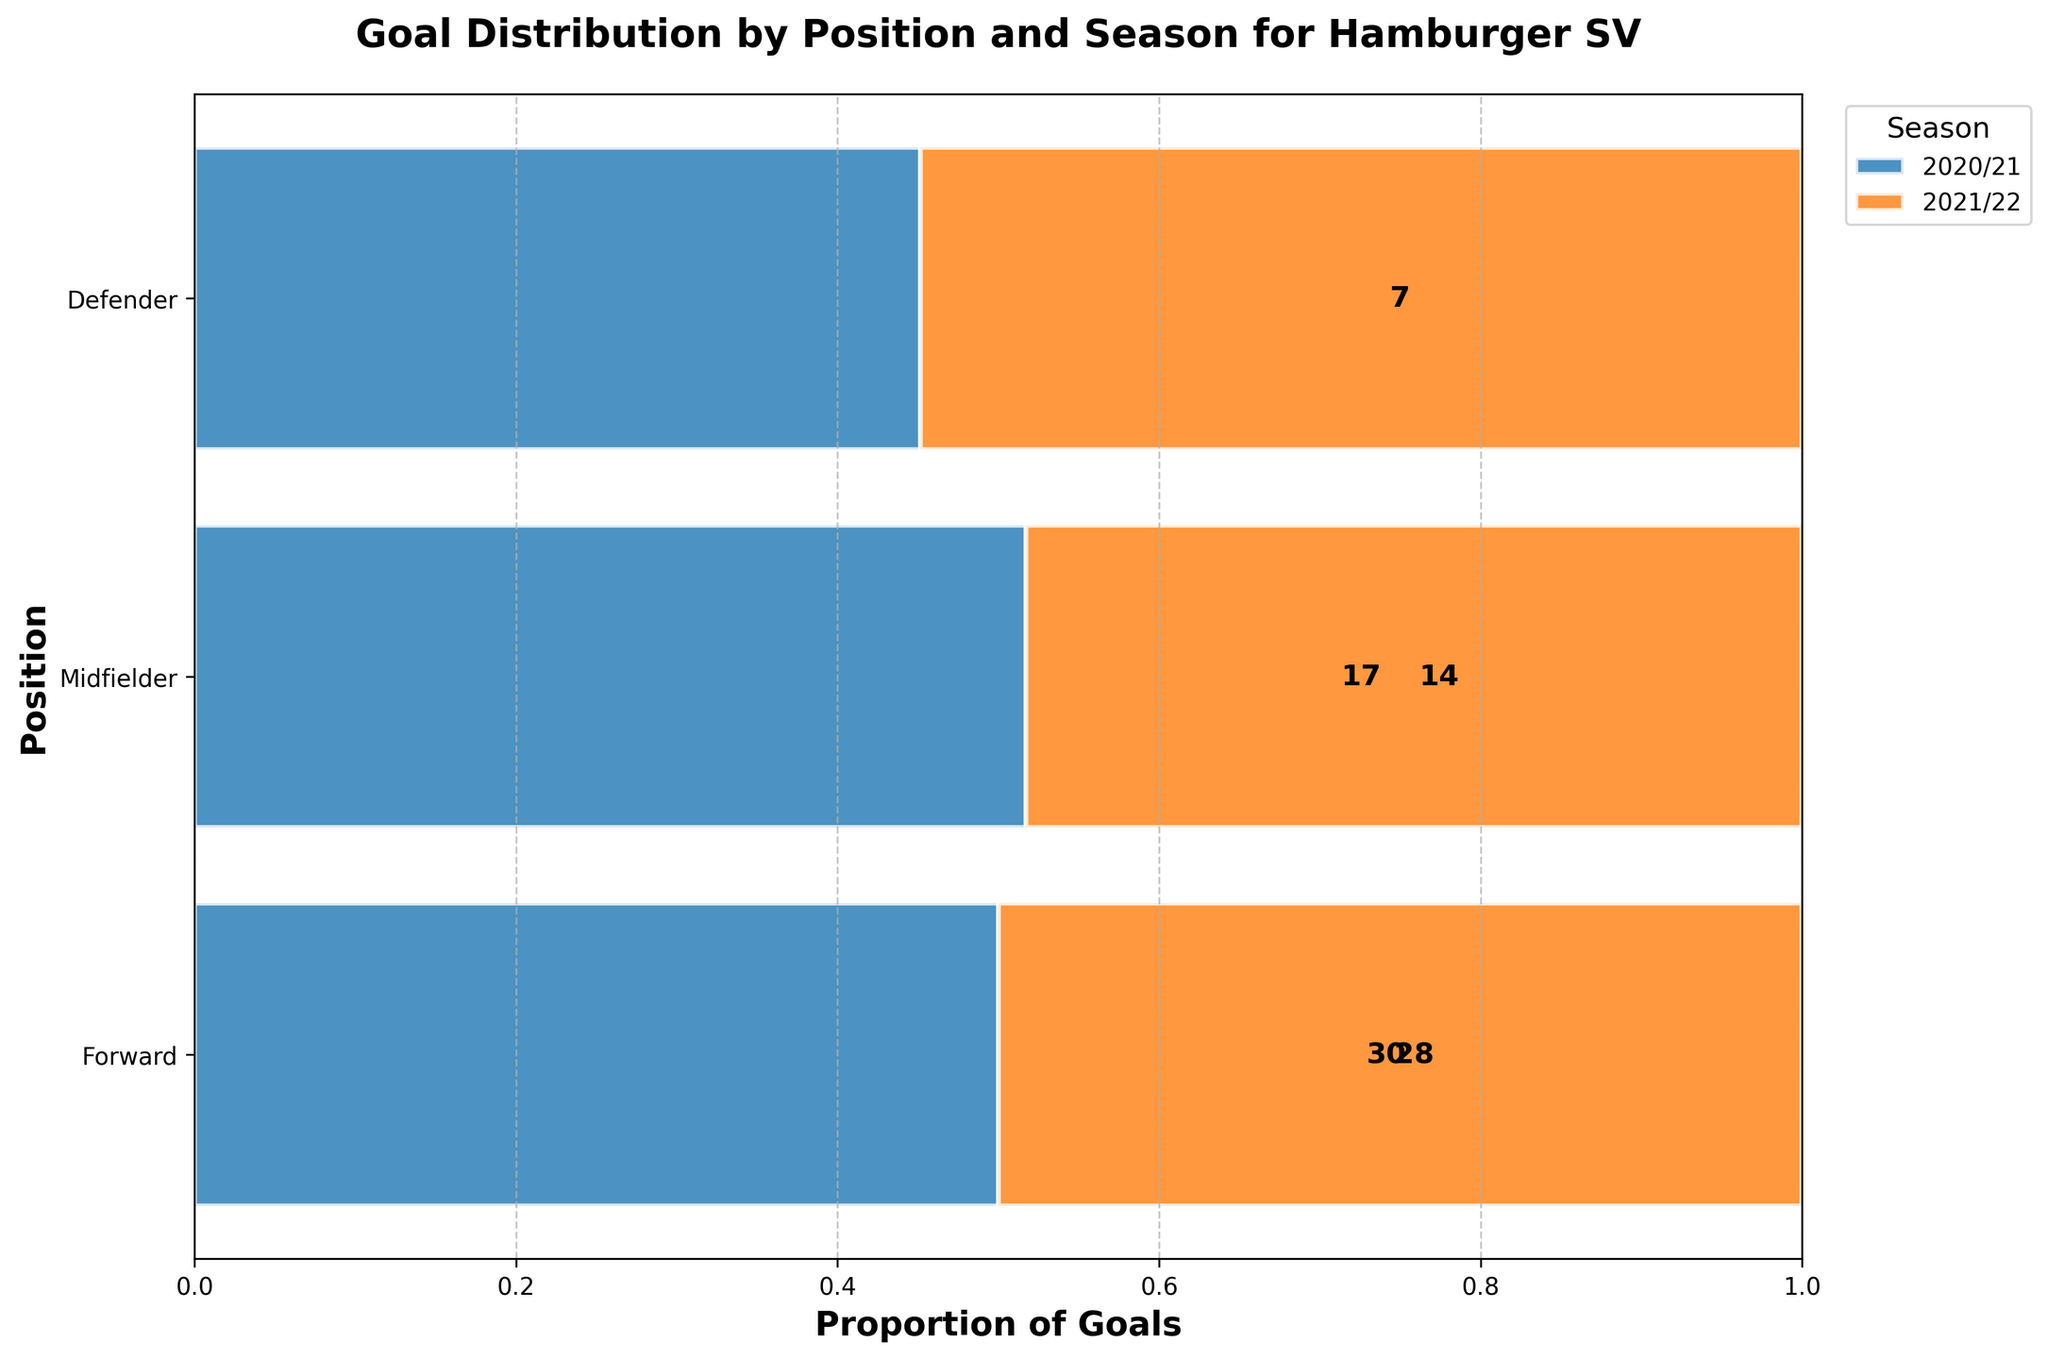What is the title of the plot? The title of the plot is shown at the top and is a brief description of what the plot is about.
Answer: Goal Distribution by Position and Season for Hamburger SV How many goals did defenders score in the 2021/22 season? To find this, locate the 'Defender' category and check the bar segment labeled '2021/22'. The number is displayed in the middle of this segment.
Answer: 7 Which season had more goals scored by midfielders, 2020/21 or 2021/22? Compare the lengths of the bars for midfielders in both seasons. The bar for 2021/22 is longer than 2020/21, indicating more goals.
Answer: 2021/22 What is the position with the least goal contribution in the 2020/21 season? Check the length of the bars for each position in the 2020/21 season. The one with the shortest bar (smallest width) has the least goals.
Answer: Defender Between forwards and midfielders, which position had a higher total goal proportion in the 2021/22 season? Compare the widths of the bars for forwards and midfielders for the 2021/22 season. The one with the wider segment has a higher proportion.
Answer: Forward How many more goals did forwards score than midfielders in the 2020/21 season? Check the count of goals for forwards and midfielders in the 2020/21 season, then find the difference: 30 (forwards) - 14 (midfielders) = 16.
Answer: 16 Which season had a balance of goal contribution across positions? A balanced goal contribution would show more uniform bar widths. Comparing the seasons, the proportions in the 2021/22 season appear more uniform across positions.
Answer: 2021/22 How many goals did Robert Glatzel score, and in which season? Identify Robert Glatzel’s name and locate the corresponding goal count. According to the data, he scored 22 goals in the 2021/22 season.
Answer: 22, 2021/22 Which position has shown a consistent goal contribution across both seasons? Check the bars for each position to see if a similar proportion of goals is maintained across seasons. Defenders have a roughly consistent contribution.
Answer: Defender Which player contributed the most to the forwards' goal tally in the 2020/21 season? Look at the players listed under the forward position for the 2020/21 season and their goal counts. Simon Terodde scored the most.
Answer: Simon Terodde 